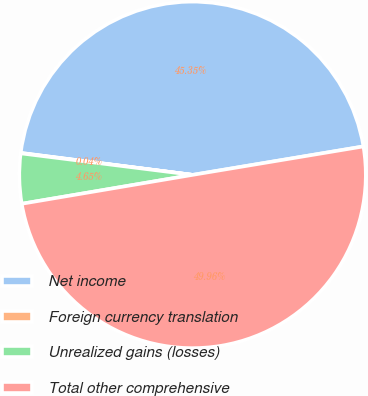<chart> <loc_0><loc_0><loc_500><loc_500><pie_chart><fcel>Net income<fcel>Foreign currency translation<fcel>Unrealized gains (losses)<fcel>Total other comprehensive<nl><fcel>45.35%<fcel>0.04%<fcel>4.65%<fcel>49.96%<nl></chart> 